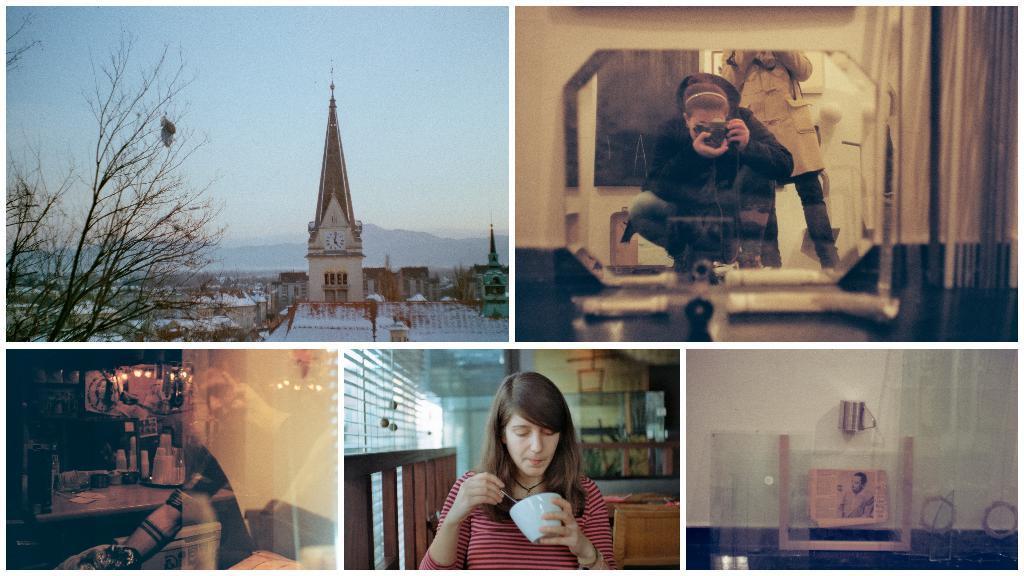How would you summarize this image in a sentence or two? n this picture I can see there is a collage of images, there is a building with snow and trees, there is a person clicking the photograph and there is a reflection of a person on the bottom left side, there is a woman holding a bowl and there is a photo frame to the bottom right side. 